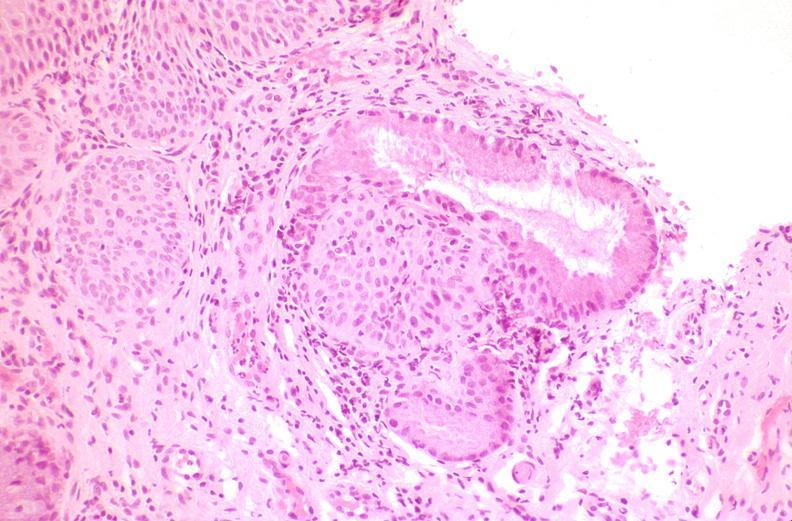what does this image show?
Answer the question using a single word or phrase. Cervix 